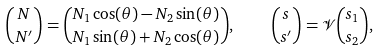<formula> <loc_0><loc_0><loc_500><loc_500>\binom { N } { N ^ { \prime } } = \binom { N _ { 1 } \cos ( \theta ) - N _ { 2 } \sin ( \theta ) } { N _ { 1 } \sin ( \theta ) + N _ { 2 } \cos ( \theta ) } , \quad \binom { s } { s ^ { \prime } } = \mathcal { V } \binom { s _ { 1 } } { s _ { 2 } } ,</formula> 